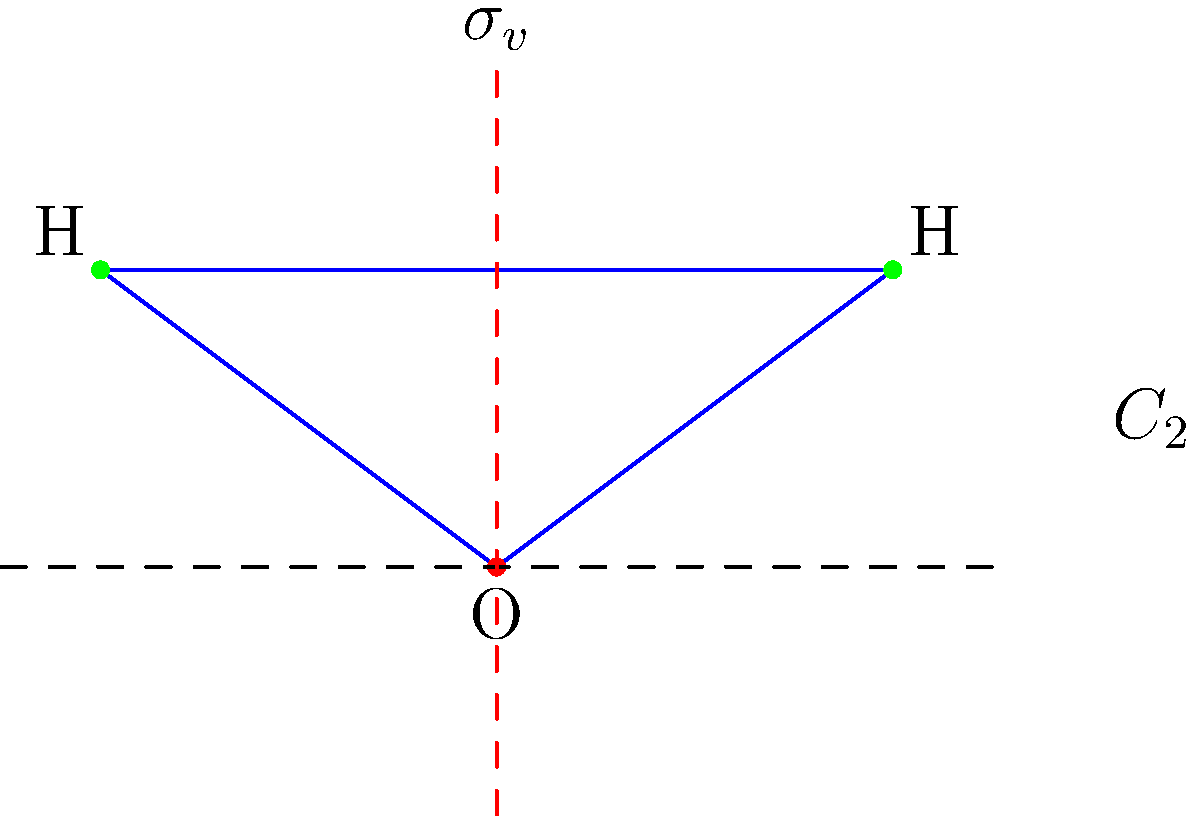Consider the water molecule (H2O) shown above. Using the C2v character table and symmetry arguments, determine which of the three vibrational modes (symmetric stretch, asymmetric stretch, and bend) are IR-active. Explain your reasoning using the selection rules for IR spectroscopy. To determine which vibrational modes are IR-active, we need to follow these steps:

1. Recall the selection rule for IR spectroscopy: A vibration is IR-active if it produces a change in the molecular dipole moment.

2. Identify the symmetry operations of the H2O molecule:
   - C2 rotation axis (vertical)
   - Two σv mirror planes (one in the molecular plane, one perpendicular to it)
   - E (identity)
   This confirms the molecule belongs to the C2v point group.

3. Examine the C2v character table:

   C2v | E   C2   σv(xz)   σv(yz)
   A1  | 1    1      1        1     z
   A2  | 1    1     -1       -1     Rz
   B1  | 1   -1      1       -1     x, Ry
   B2  | 1   -1     -1        1     y, Rx

4. The dipole moment transforms as x, y, and z, which correspond to B1, B2, and A1 irreducible representations, respectively.

5. Analyze each vibrational mode:
   a) Symmetric stretch: A1 symmetry
   b) Asymmetric stretch: B1 symmetry
   c) Bend: A1 symmetry

6. Compare the symmetries of the vibrational modes with the symmetries of the dipole moment components:
   - A1 (symmetric stretch and bend) overlaps with z (A1)
   - B1 (asymmetric stretch) overlaps with x (B1)

Therefore, all three vibrational modes of H2O are IR-active because they all produce a change in at least one component of the dipole moment.
Answer: All three vibrational modes (symmetric stretch, asymmetric stretch, and bend) are IR-active. 